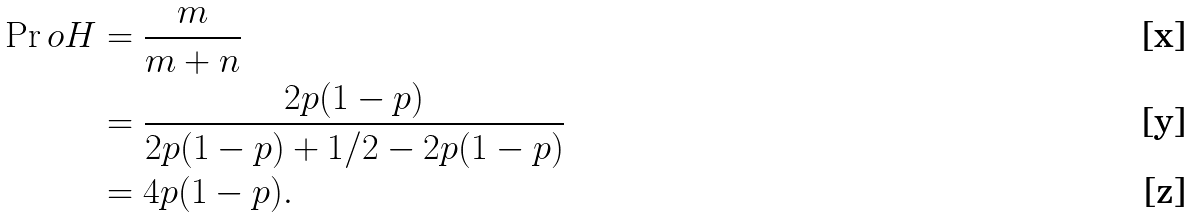Convert formula to latex. <formula><loc_0><loc_0><loc_500><loc_500>\Pr o { H } & = \frac { m } { m + n } \\ & = \frac { 2 p ( 1 - p ) } { 2 p ( 1 - p ) + 1 / 2 - 2 p ( 1 - p ) } \\ & = 4 p ( 1 - p ) .</formula> 